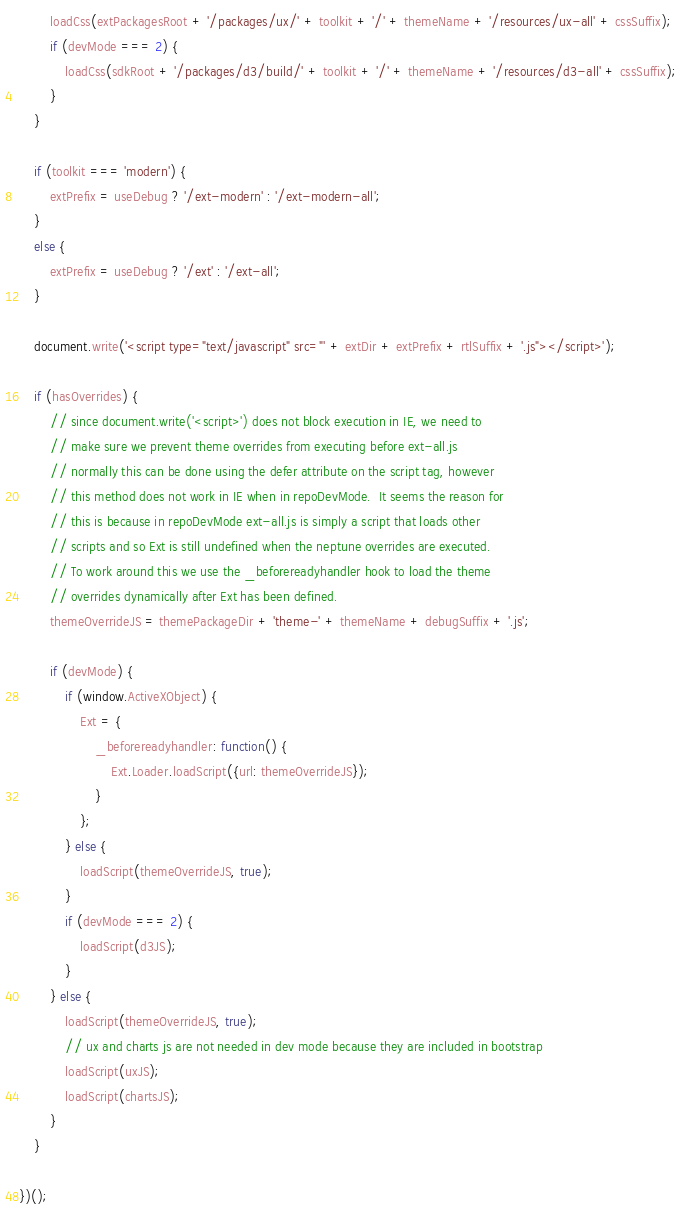Convert code to text. <code><loc_0><loc_0><loc_500><loc_500><_JavaScript_>        loadCss(extPackagesRoot + '/packages/ux/' + toolkit + '/' + themeName + '/resources/ux-all' + cssSuffix);
        if (devMode === 2) {
            loadCss(sdkRoot + '/packages/d3/build/' + toolkit + '/' + themeName + '/resources/d3-all' + cssSuffix);
        }
    }

    if (toolkit === 'modern') {
        extPrefix = useDebug ? '/ext-modern' : '/ext-modern-all';
    }
    else {
        extPrefix = useDebug ? '/ext' : '/ext-all';
    }
    
    document.write('<script type="text/javascript" src="' + extDir + extPrefix + rtlSuffix + '.js"></script>');

    if (hasOverrides) {
        // since document.write('<script>') does not block execution in IE, we need to
        // make sure we prevent theme overrides from executing before ext-all.js
        // normally this can be done using the defer attribute on the script tag, however
        // this method does not work in IE when in repoDevMode.  It seems the reason for
        // this is because in repoDevMode ext-all.js is simply a script that loads other
        // scripts and so Ext is still undefined when the neptune overrides are executed.
        // To work around this we use the _beforereadyhandler hook to load the theme
        // overrides dynamically after Ext has been defined.
        themeOverrideJS = themePackageDir + 'theme-' + themeName + debugSuffix + '.js';

        if (devMode) {
            if (window.ActiveXObject) {
                Ext = {
                    _beforereadyhandler: function() {
                        Ext.Loader.loadScript({url: themeOverrideJS});
                    }
                };
            } else {
                loadScript(themeOverrideJS, true);
            }
            if (devMode === 2) {
                loadScript(d3JS);
            }
        } else {
            loadScript(themeOverrideJS, true);
            // ux and charts js are not needed in dev mode because they are included in bootstrap
            loadScript(uxJS);
            loadScript(chartsJS);
        }
    }

})();
</code> 